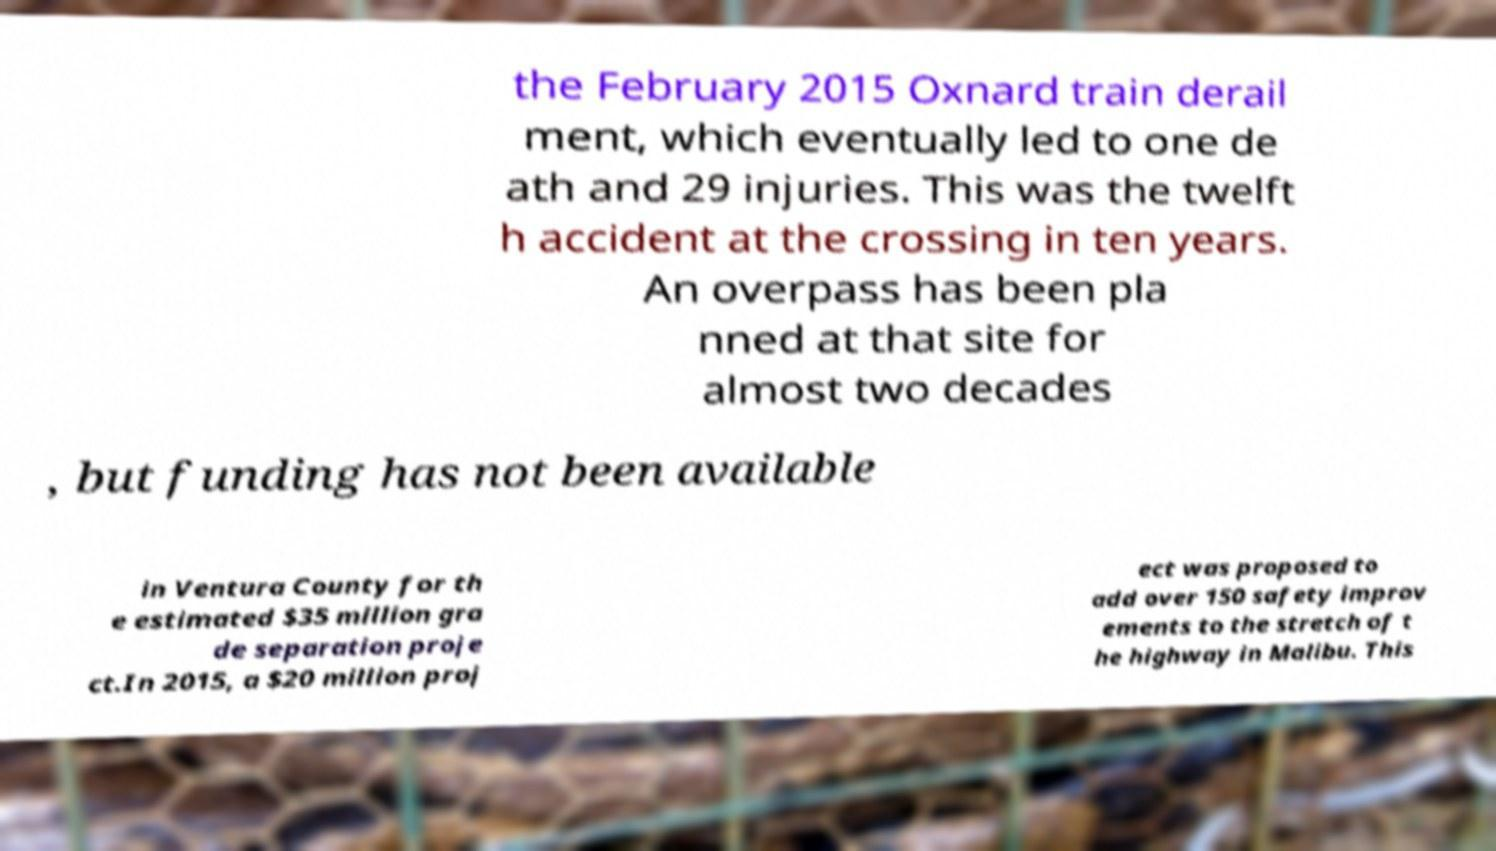There's text embedded in this image that I need extracted. Can you transcribe it verbatim? the February 2015 Oxnard train derail ment, which eventually led to one de ath and 29 injuries. This was the twelft h accident at the crossing in ten years. An overpass has been pla nned at that site for almost two decades , but funding has not been available in Ventura County for th e estimated $35 million gra de separation proje ct.In 2015, a $20 million proj ect was proposed to add over 150 safety improv ements to the stretch of t he highway in Malibu. This 